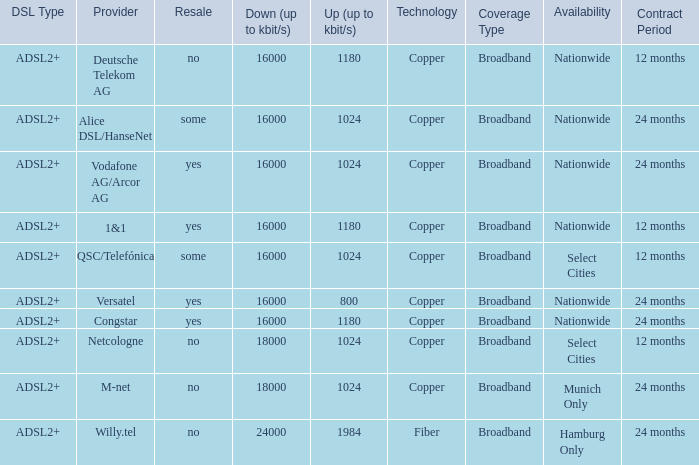What are all the dsl type offered by the M-Net telecom company? ADSL2+. 